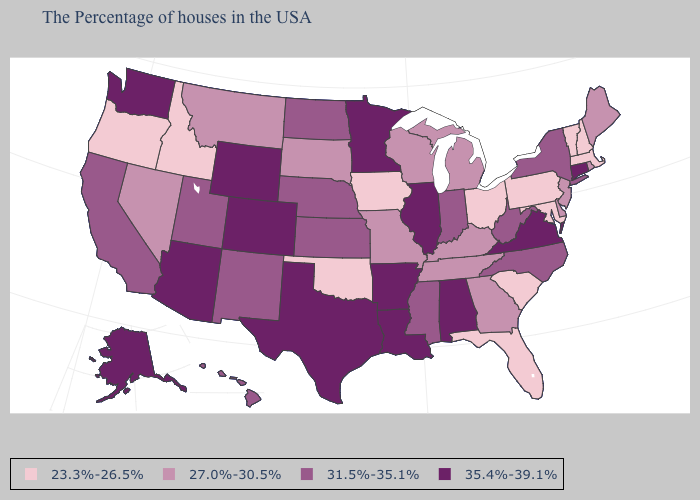Does California have a lower value than Iowa?
Give a very brief answer. No. Name the states that have a value in the range 23.3%-26.5%?
Keep it brief. Massachusetts, New Hampshire, Vermont, Maryland, Pennsylvania, South Carolina, Ohio, Florida, Iowa, Oklahoma, Idaho, Oregon. Does Colorado have a higher value than New York?
Concise answer only. Yes. What is the highest value in the USA?
Keep it brief. 35.4%-39.1%. What is the highest value in states that border Maryland?
Write a very short answer. 35.4%-39.1%. Among the states that border Arizona , which have the lowest value?
Give a very brief answer. Nevada. What is the value of Alabama?
Quick response, please. 35.4%-39.1%. Name the states that have a value in the range 31.5%-35.1%?
Answer briefly. New York, North Carolina, West Virginia, Indiana, Mississippi, Kansas, Nebraska, North Dakota, New Mexico, Utah, California, Hawaii. Does Rhode Island have a lower value than Kentucky?
Give a very brief answer. No. How many symbols are there in the legend?
Quick response, please. 4. Among the states that border Colorado , which have the lowest value?
Keep it brief. Oklahoma. What is the lowest value in states that border Tennessee?
Keep it brief. 27.0%-30.5%. Does Idaho have the same value as Rhode Island?
Answer briefly. No. What is the highest value in the West ?
Answer briefly. 35.4%-39.1%. Among the states that border Massachusetts , which have the highest value?
Short answer required. Connecticut. 